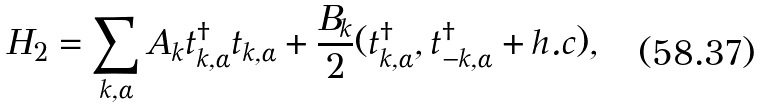<formula> <loc_0><loc_0><loc_500><loc_500>H _ { 2 } = \sum _ { k , \alpha } A _ { k } t ^ { \dag } _ { k , \alpha } t _ { k , \alpha } + \frac { B _ { k } } { 2 } ( t ^ { \dag } _ { k , \alpha } , t ^ { \dag } _ { - k , \alpha } + h . c ) ,</formula> 